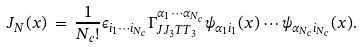<formula> <loc_0><loc_0><loc_500><loc_500>J _ { N } ( x ) \, = \, \frac { 1 } { N _ { c } ! } \epsilon _ { i _ { 1 } \cdots i _ { N _ { c } } } \Gamma ^ { \alpha _ { 1 } \cdots \alpha _ { N _ { c } } } _ { J J _ { 3 } T T _ { 3 } } \psi _ { \alpha _ { 1 } i _ { 1 } } ( x ) \cdots \psi _ { \alpha _ { N _ { c } } i _ { N _ { c } } } ( x ) .</formula> 